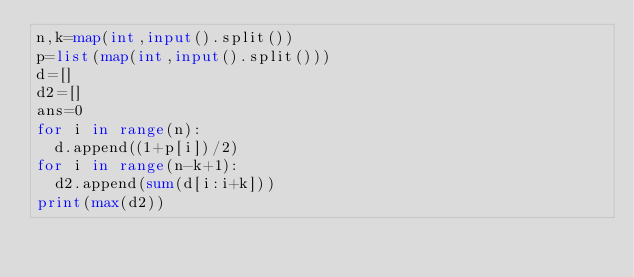<code> <loc_0><loc_0><loc_500><loc_500><_Python_>n,k=map(int,input().split())
p=list(map(int,input().split()))
d=[]
d2=[]
ans=0
for i in range(n):
  d.append((1+p[i])/2)
for i in range(n-k+1):
  d2.append(sum(d[i:i+k]))
print(max(d2))</code> 